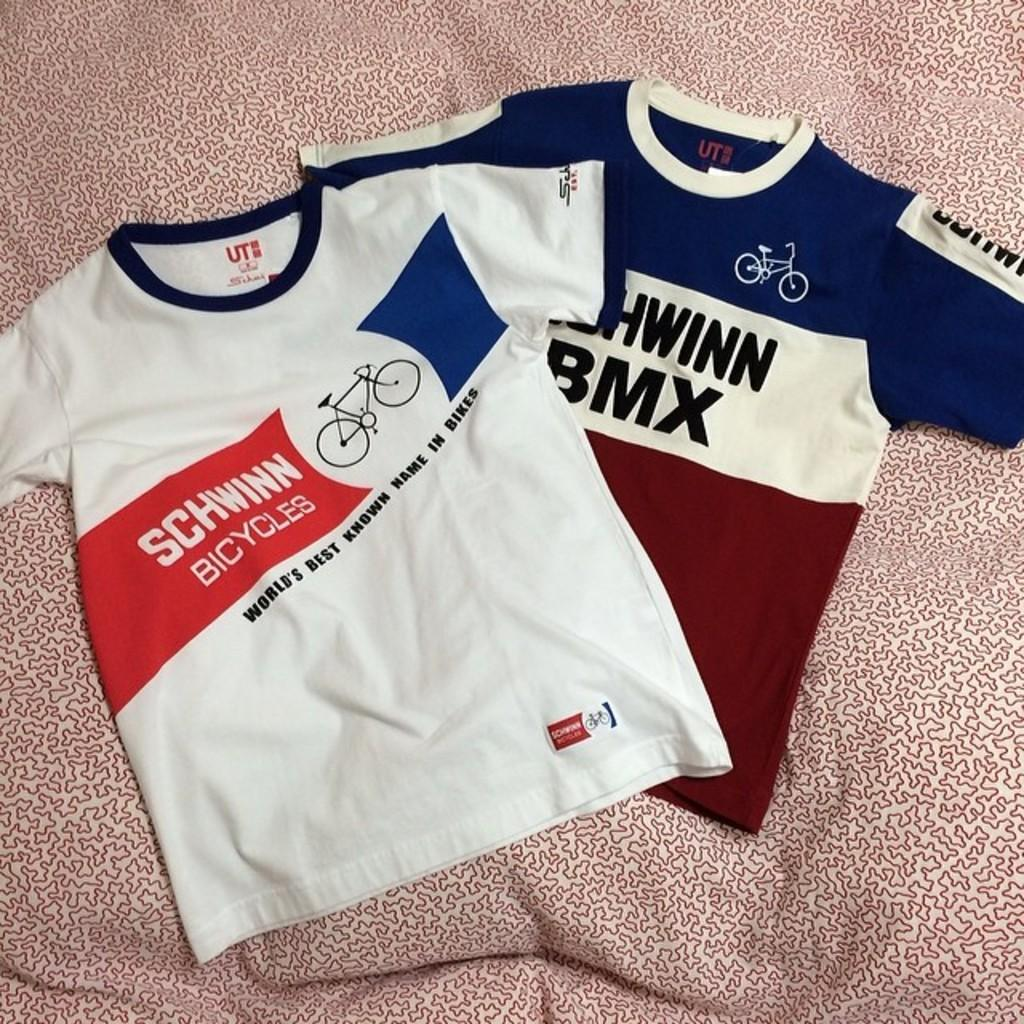<image>
Summarize the visual content of the image. Two Schiwinn Bicycles shirts lying on a bed spread with one shirt being white with blue trim and the other shirt blue,white and red striped 